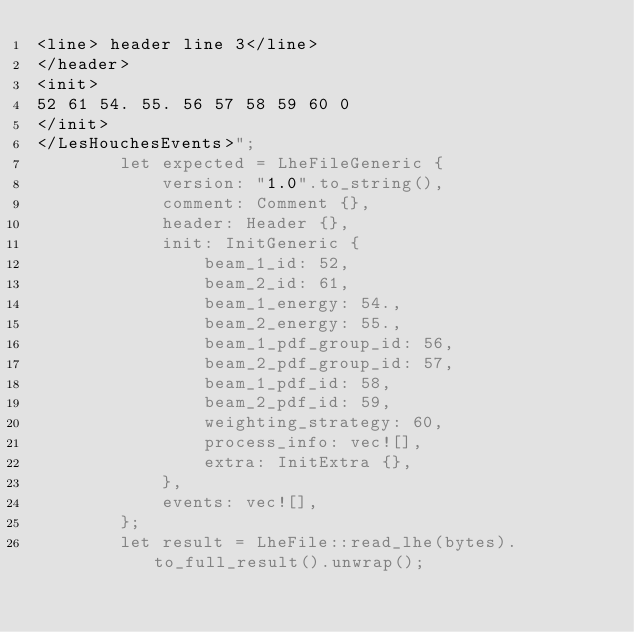<code> <loc_0><loc_0><loc_500><loc_500><_Rust_><line> header line 3</line>
</header>
<init>
52 61 54. 55. 56 57 58 59 60 0
</init>
</LesHouchesEvents>";
        let expected = LheFileGeneric {
            version: "1.0".to_string(),
            comment: Comment {},
            header: Header {},
            init: InitGeneric {
                beam_1_id: 52,
                beam_2_id: 61,
                beam_1_energy: 54.,
                beam_2_energy: 55.,
                beam_1_pdf_group_id: 56,
                beam_2_pdf_group_id: 57,
                beam_1_pdf_id: 58,
                beam_2_pdf_id: 59,
                weighting_strategy: 60,
                process_info: vec![],
                extra: InitExtra {},
            },
            events: vec![],
        };
        let result = LheFile::read_lhe(bytes).to_full_result().unwrap();</code> 